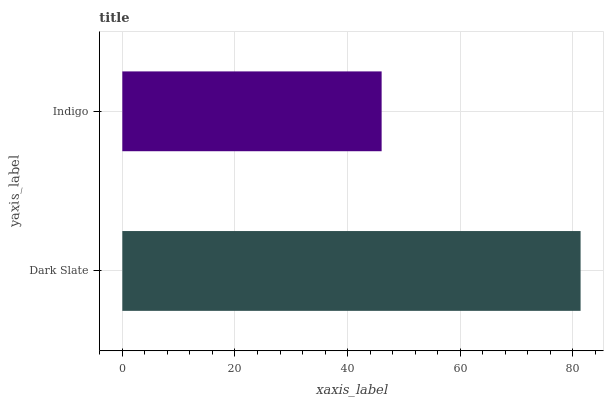Is Indigo the minimum?
Answer yes or no. Yes. Is Dark Slate the maximum?
Answer yes or no. Yes. Is Indigo the maximum?
Answer yes or no. No. Is Dark Slate greater than Indigo?
Answer yes or no. Yes. Is Indigo less than Dark Slate?
Answer yes or no. Yes. Is Indigo greater than Dark Slate?
Answer yes or no. No. Is Dark Slate less than Indigo?
Answer yes or no. No. Is Dark Slate the high median?
Answer yes or no. Yes. Is Indigo the low median?
Answer yes or no. Yes. Is Indigo the high median?
Answer yes or no. No. Is Dark Slate the low median?
Answer yes or no. No. 